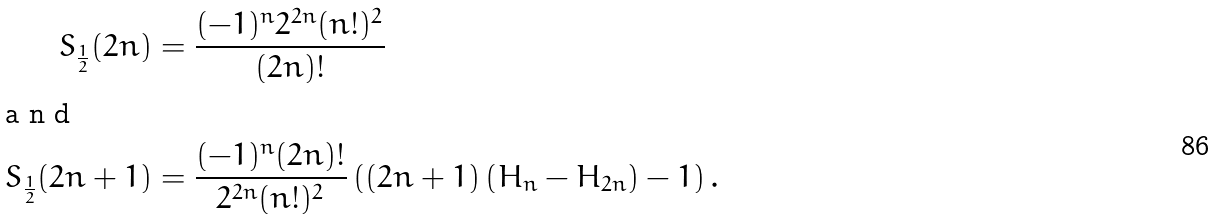Convert formula to latex. <formula><loc_0><loc_0><loc_500><loc_500>S _ { \frac { 1 } { 2 } } ( 2 n ) & = \frac { ( - 1 ) ^ { n } 2 ^ { 2 n } ( n ! ) ^ { 2 } } { ( 2 n ) ! } \\ \intertext { a n d } S _ { \frac { 1 } { 2 } } ( 2 n + 1 ) & = \frac { ( - 1 ) ^ { n } ( 2 n ) ! } { 2 ^ { 2 n } ( n ! ) ^ { 2 } } \left ( ( 2 n + 1 ) \left ( H _ { n } - H _ { 2 n } \right ) - 1 \right ) .</formula> 